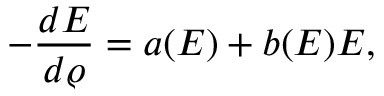<formula> <loc_0><loc_0><loc_500><loc_500>- \frac { d E } { d \varrho } = a ( E ) + b ( E ) E ,</formula> 